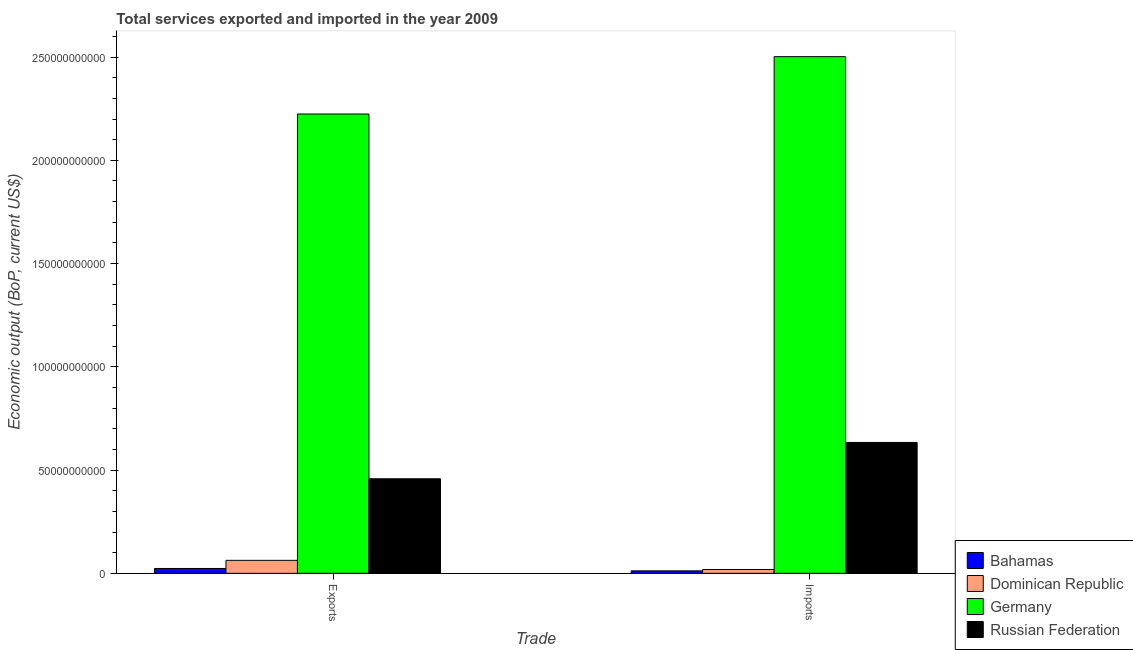How many groups of bars are there?
Make the answer very short. 2. Are the number of bars per tick equal to the number of legend labels?
Your answer should be very brief. Yes. Are the number of bars on each tick of the X-axis equal?
Your answer should be very brief. Yes. How many bars are there on the 2nd tick from the left?
Give a very brief answer. 4. What is the label of the 1st group of bars from the left?
Keep it short and to the point. Exports. What is the amount of service imports in Dominican Republic?
Give a very brief answer. 1.86e+09. Across all countries, what is the maximum amount of service exports?
Offer a terse response. 2.22e+11. Across all countries, what is the minimum amount of service imports?
Offer a terse response. 1.20e+09. In which country was the amount of service exports minimum?
Make the answer very short. Bahamas. What is the total amount of service imports in the graph?
Offer a very short reply. 3.17e+11. What is the difference between the amount of service exports in Russian Federation and that in Germany?
Make the answer very short. -1.77e+11. What is the difference between the amount of service exports in Dominican Republic and the amount of service imports in Germany?
Your answer should be compact. -2.44e+11. What is the average amount of service imports per country?
Ensure brevity in your answer.  7.92e+1. What is the difference between the amount of service imports and amount of service exports in Dominican Republic?
Provide a succinct answer. -4.44e+09. What is the ratio of the amount of service imports in Germany to that in Bahamas?
Offer a terse response. 209.2. Is the amount of service imports in Germany less than that in Bahamas?
Your answer should be compact. No. What does the 2nd bar from the left in Imports represents?
Make the answer very short. Dominican Republic. What does the 1st bar from the right in Exports represents?
Your response must be concise. Russian Federation. What is the difference between two consecutive major ticks on the Y-axis?
Provide a short and direct response. 5.00e+1. Are the values on the major ticks of Y-axis written in scientific E-notation?
Provide a short and direct response. No. Does the graph contain grids?
Offer a very short reply. No. How many legend labels are there?
Offer a very short reply. 4. How are the legend labels stacked?
Keep it short and to the point. Vertical. What is the title of the graph?
Offer a very short reply. Total services exported and imported in the year 2009. What is the label or title of the X-axis?
Provide a short and direct response. Trade. What is the label or title of the Y-axis?
Keep it short and to the point. Economic output (BoP, current US$). What is the Economic output (BoP, current US$) in Bahamas in Exports?
Provide a short and direct response. 2.35e+09. What is the Economic output (BoP, current US$) in Dominican Republic in Exports?
Your answer should be very brief. 6.29e+09. What is the Economic output (BoP, current US$) in Germany in Exports?
Your answer should be very brief. 2.22e+11. What is the Economic output (BoP, current US$) of Russian Federation in Exports?
Your response must be concise. 4.58e+1. What is the Economic output (BoP, current US$) in Bahamas in Imports?
Your response must be concise. 1.20e+09. What is the Economic output (BoP, current US$) in Dominican Republic in Imports?
Your response must be concise. 1.86e+09. What is the Economic output (BoP, current US$) in Germany in Imports?
Offer a terse response. 2.50e+11. What is the Economic output (BoP, current US$) of Russian Federation in Imports?
Keep it short and to the point. 6.34e+1. Across all Trade, what is the maximum Economic output (BoP, current US$) in Bahamas?
Your answer should be compact. 2.35e+09. Across all Trade, what is the maximum Economic output (BoP, current US$) in Dominican Republic?
Offer a very short reply. 6.29e+09. Across all Trade, what is the maximum Economic output (BoP, current US$) of Germany?
Your answer should be compact. 2.50e+11. Across all Trade, what is the maximum Economic output (BoP, current US$) in Russian Federation?
Make the answer very short. 6.34e+1. Across all Trade, what is the minimum Economic output (BoP, current US$) of Bahamas?
Provide a succinct answer. 1.20e+09. Across all Trade, what is the minimum Economic output (BoP, current US$) in Dominican Republic?
Provide a short and direct response. 1.86e+09. Across all Trade, what is the minimum Economic output (BoP, current US$) in Germany?
Your answer should be compact. 2.22e+11. Across all Trade, what is the minimum Economic output (BoP, current US$) in Russian Federation?
Provide a succinct answer. 4.58e+1. What is the total Economic output (BoP, current US$) of Bahamas in the graph?
Your answer should be very brief. 3.55e+09. What is the total Economic output (BoP, current US$) in Dominican Republic in the graph?
Keep it short and to the point. 8.15e+09. What is the total Economic output (BoP, current US$) of Germany in the graph?
Your answer should be very brief. 4.73e+11. What is the total Economic output (BoP, current US$) in Russian Federation in the graph?
Give a very brief answer. 1.09e+11. What is the difference between the Economic output (BoP, current US$) in Bahamas in Exports and that in Imports?
Provide a short and direct response. 1.15e+09. What is the difference between the Economic output (BoP, current US$) of Dominican Republic in Exports and that in Imports?
Your response must be concise. 4.44e+09. What is the difference between the Economic output (BoP, current US$) in Germany in Exports and that in Imports?
Give a very brief answer. -2.78e+1. What is the difference between the Economic output (BoP, current US$) of Russian Federation in Exports and that in Imports?
Offer a terse response. -1.76e+1. What is the difference between the Economic output (BoP, current US$) of Bahamas in Exports and the Economic output (BoP, current US$) of Dominican Republic in Imports?
Offer a terse response. 4.94e+08. What is the difference between the Economic output (BoP, current US$) in Bahamas in Exports and the Economic output (BoP, current US$) in Germany in Imports?
Offer a very short reply. -2.48e+11. What is the difference between the Economic output (BoP, current US$) in Bahamas in Exports and the Economic output (BoP, current US$) in Russian Federation in Imports?
Offer a terse response. -6.10e+1. What is the difference between the Economic output (BoP, current US$) of Dominican Republic in Exports and the Economic output (BoP, current US$) of Germany in Imports?
Give a very brief answer. -2.44e+11. What is the difference between the Economic output (BoP, current US$) in Dominican Republic in Exports and the Economic output (BoP, current US$) in Russian Federation in Imports?
Give a very brief answer. -5.71e+1. What is the difference between the Economic output (BoP, current US$) in Germany in Exports and the Economic output (BoP, current US$) in Russian Federation in Imports?
Offer a terse response. 1.59e+11. What is the average Economic output (BoP, current US$) of Bahamas per Trade?
Your response must be concise. 1.77e+09. What is the average Economic output (BoP, current US$) in Dominican Republic per Trade?
Provide a succinct answer. 4.07e+09. What is the average Economic output (BoP, current US$) in Germany per Trade?
Your answer should be compact. 2.36e+11. What is the average Economic output (BoP, current US$) in Russian Federation per Trade?
Offer a terse response. 5.46e+1. What is the difference between the Economic output (BoP, current US$) of Bahamas and Economic output (BoP, current US$) of Dominican Republic in Exports?
Keep it short and to the point. -3.94e+09. What is the difference between the Economic output (BoP, current US$) in Bahamas and Economic output (BoP, current US$) in Germany in Exports?
Give a very brief answer. -2.20e+11. What is the difference between the Economic output (BoP, current US$) of Bahamas and Economic output (BoP, current US$) of Russian Federation in Exports?
Make the answer very short. -4.34e+1. What is the difference between the Economic output (BoP, current US$) of Dominican Republic and Economic output (BoP, current US$) of Germany in Exports?
Your answer should be compact. -2.16e+11. What is the difference between the Economic output (BoP, current US$) of Dominican Republic and Economic output (BoP, current US$) of Russian Federation in Exports?
Offer a terse response. -3.95e+1. What is the difference between the Economic output (BoP, current US$) in Germany and Economic output (BoP, current US$) in Russian Federation in Exports?
Offer a very short reply. 1.77e+11. What is the difference between the Economic output (BoP, current US$) in Bahamas and Economic output (BoP, current US$) in Dominican Republic in Imports?
Make the answer very short. -6.61e+08. What is the difference between the Economic output (BoP, current US$) of Bahamas and Economic output (BoP, current US$) of Germany in Imports?
Offer a terse response. -2.49e+11. What is the difference between the Economic output (BoP, current US$) of Bahamas and Economic output (BoP, current US$) of Russian Federation in Imports?
Give a very brief answer. -6.22e+1. What is the difference between the Economic output (BoP, current US$) in Dominican Republic and Economic output (BoP, current US$) in Germany in Imports?
Keep it short and to the point. -2.48e+11. What is the difference between the Economic output (BoP, current US$) in Dominican Republic and Economic output (BoP, current US$) in Russian Federation in Imports?
Your answer should be compact. -6.15e+1. What is the difference between the Economic output (BoP, current US$) in Germany and Economic output (BoP, current US$) in Russian Federation in Imports?
Make the answer very short. 1.87e+11. What is the ratio of the Economic output (BoP, current US$) in Bahamas in Exports to that in Imports?
Give a very brief answer. 1.97. What is the ratio of the Economic output (BoP, current US$) in Dominican Republic in Exports to that in Imports?
Ensure brevity in your answer.  3.39. What is the ratio of the Economic output (BoP, current US$) in Germany in Exports to that in Imports?
Your answer should be very brief. 0.89. What is the ratio of the Economic output (BoP, current US$) of Russian Federation in Exports to that in Imports?
Provide a short and direct response. 0.72. What is the difference between the highest and the second highest Economic output (BoP, current US$) of Bahamas?
Offer a very short reply. 1.15e+09. What is the difference between the highest and the second highest Economic output (BoP, current US$) of Dominican Republic?
Offer a terse response. 4.44e+09. What is the difference between the highest and the second highest Economic output (BoP, current US$) of Germany?
Offer a very short reply. 2.78e+1. What is the difference between the highest and the second highest Economic output (BoP, current US$) in Russian Federation?
Provide a short and direct response. 1.76e+1. What is the difference between the highest and the lowest Economic output (BoP, current US$) of Bahamas?
Make the answer very short. 1.15e+09. What is the difference between the highest and the lowest Economic output (BoP, current US$) of Dominican Republic?
Your response must be concise. 4.44e+09. What is the difference between the highest and the lowest Economic output (BoP, current US$) in Germany?
Your answer should be very brief. 2.78e+1. What is the difference between the highest and the lowest Economic output (BoP, current US$) in Russian Federation?
Offer a very short reply. 1.76e+1. 